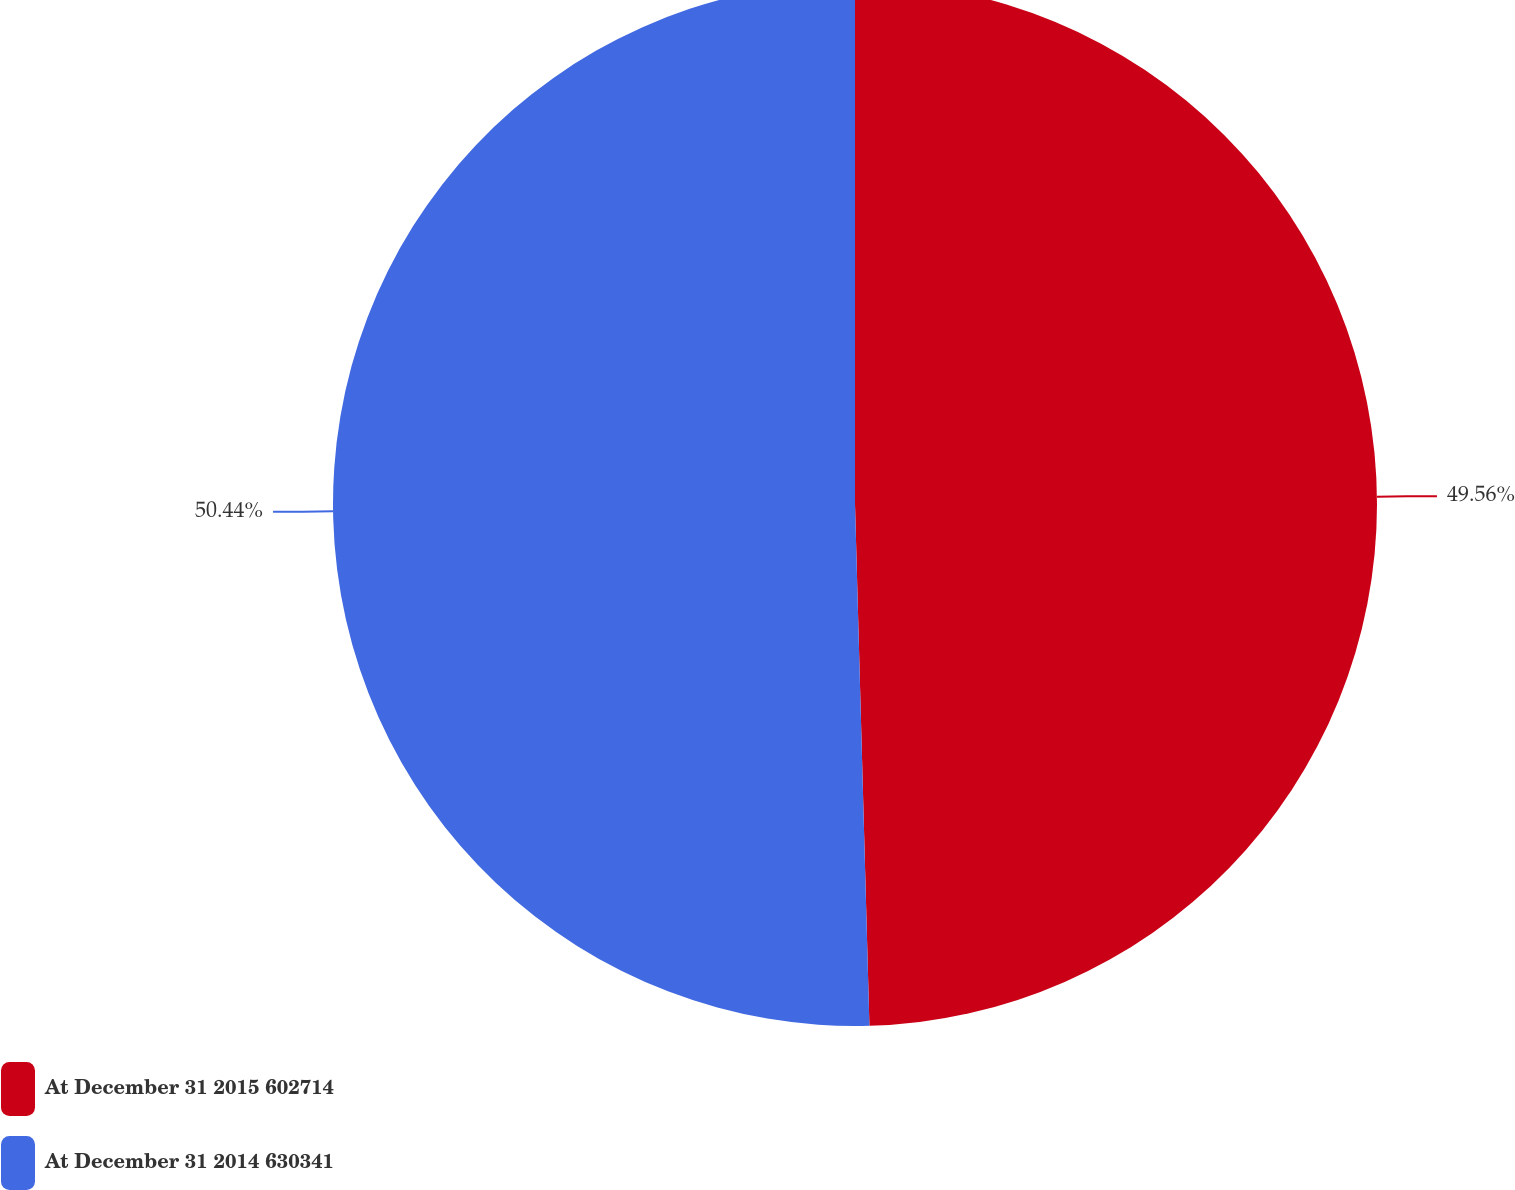<chart> <loc_0><loc_0><loc_500><loc_500><pie_chart><fcel>At December 31 2015 602714<fcel>At December 31 2014 630341<nl><fcel>49.56%<fcel>50.44%<nl></chart> 